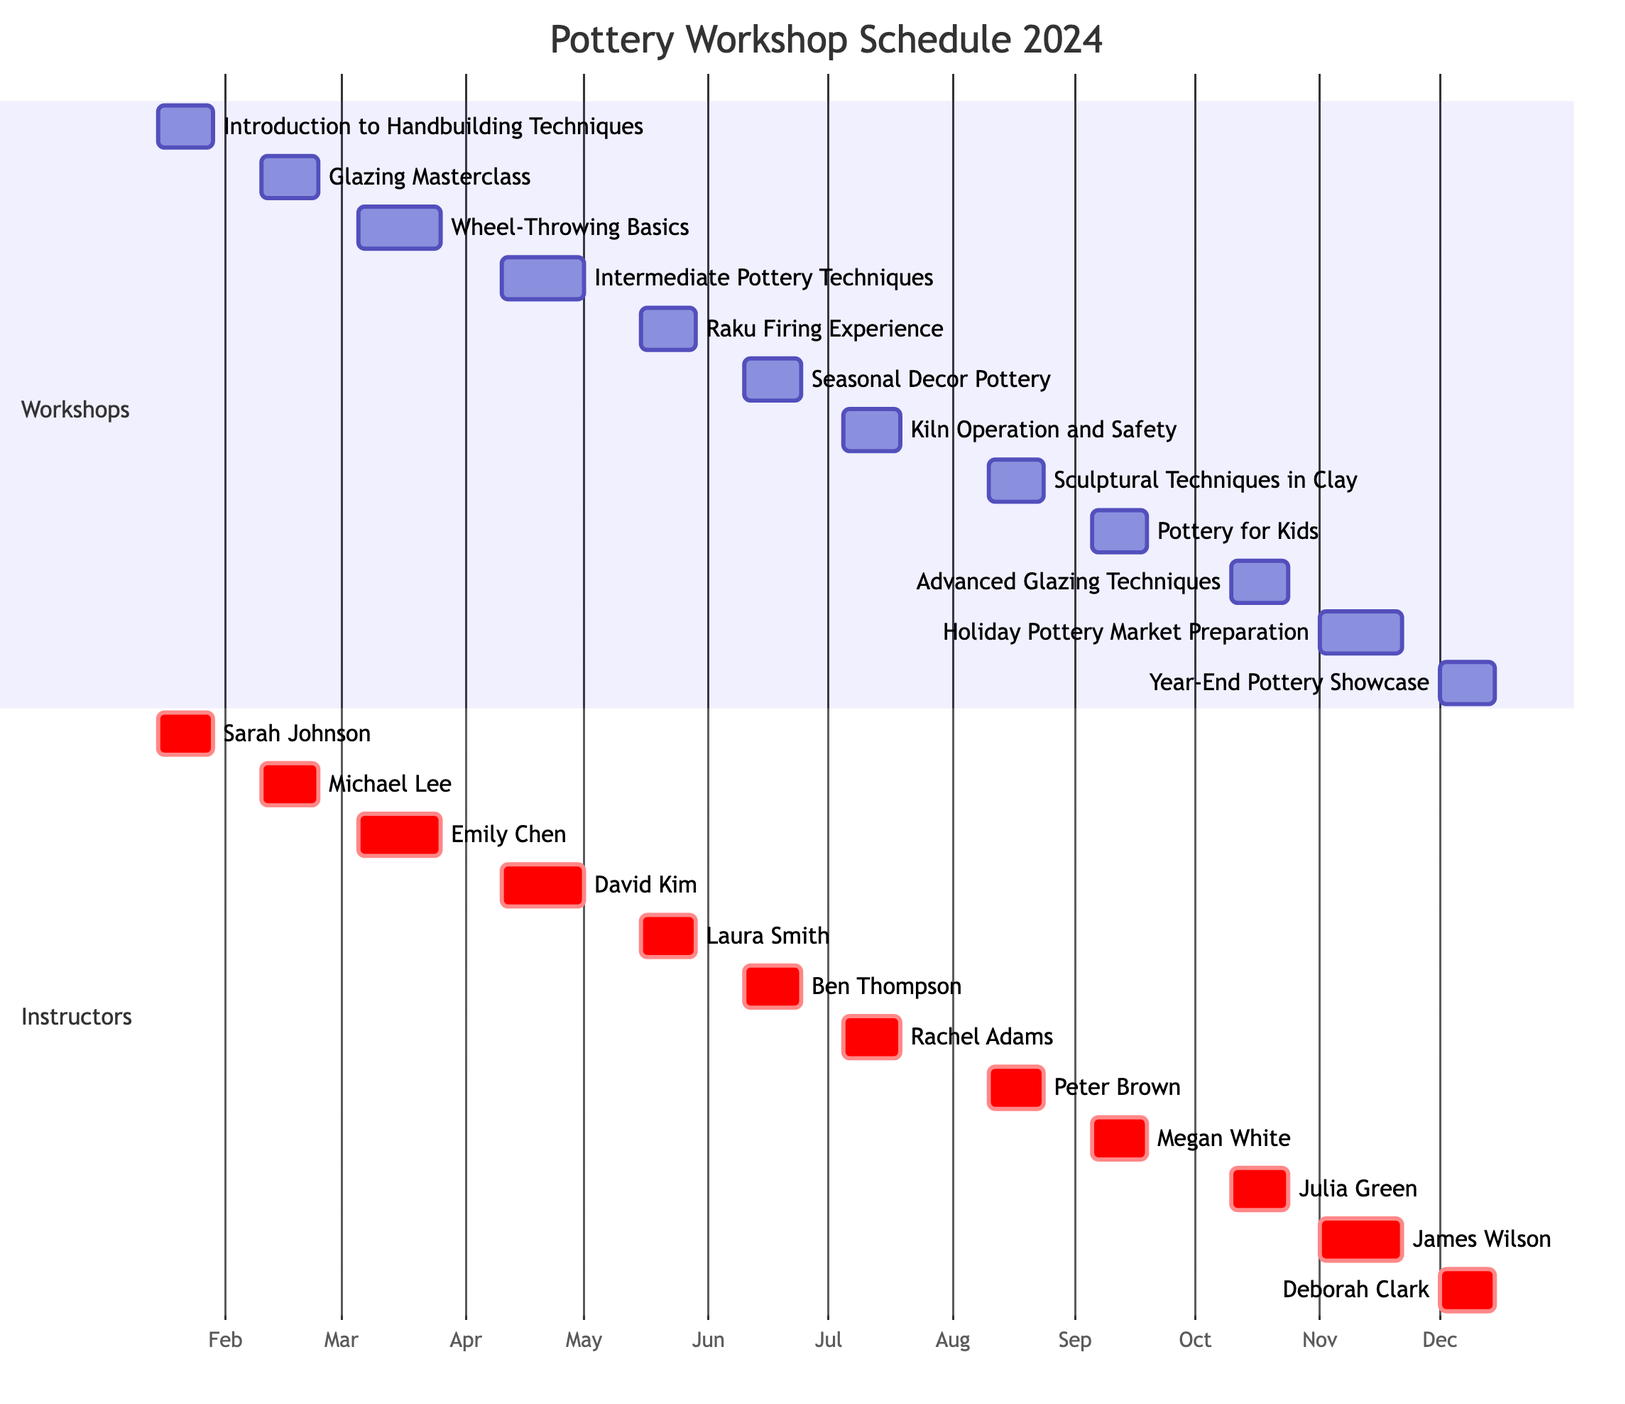What workshop starts on March 5th? By reviewing the timeline of workshops in the Gantt chart, we see that the workshop titled "Wheel-Throwing Basics" has a marked start date of March 5th, 2024.
Answer: Wheel-Throwing Basics How many weeks does the "Holiday Pottery Market Preparation" workshop run? The Gantt chart shows that this workshop is scheduled to run from November 1st to November 22nd, 2024. The duration spans three weeks, as indicated by the scheduling format in the chart.
Answer: 3 weeks Which instructor teaches the "Advanced Glazing Techniques"? Looking at the instructor's section of the Gantt chart, we find that "Julia Green" is listed next to the "Advanced Glazing Techniques" workshop, which is set for October 10th to October 24th, 2024.
Answer: Julia Green What is the duration of the "Raku Firing Experience"? The Gantt chart specifies that the "Raku Firing Experience" runs from May 15th to May 29th, 2024. This span covers two weeks, as represented by the duration indicated in the diagram.
Answer: 2 weeks Which workshop follows "Kiln Operation and Safety"? The Gantt chart lists workshops sequentially, and after "Kiln Operation and Safety," which ends on July 19th, the next workshop is "Sculptural Techniques in Clay," which starts on August 10th, 2024.
Answer: Sculptural Techniques in Clay Which instructor is available for the "Seasonal Decor Pottery" workshop? By examining the Gantt chart, we see that the instructor assigned to the "Seasonal Decor Pottery" workshop, scheduled from June 10th to June 24th, 2024, is "Ben Thompson."
Answer: Ben Thompson How many workshops are scheduled in the first half of the year (from January to June)? The Gantt chart lists six workshops scheduled from January 15th through June 24th, 2024, including: Introduction to Handbuilding Techniques, Glazing Masterclass, Wheel-Throwing Basics, Intermediate Pottery Techniques, Raku Firing Experience, and Seasonal Decor Pottery.
Answer: 6 workshops When does the "Year-End Pottery Showcase" occur? According to the Gantt chart, the "Year-End Pottery Showcase" is scheduled to take place from December 1st to December 15th, 2024.
Answer: December 1st to December 15th Which month has the maximum number of workshops scheduled? By analyzing the timeline in the Gantt chart, we find that November has the most workshops, specifically the "Holiday Pottery Market Preparation" workshop, running from November 1st to November 22nd; other months have fewer workshops overlapping.
Answer: November 